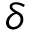<formula> <loc_0><loc_0><loc_500><loc_500>\delta</formula> 